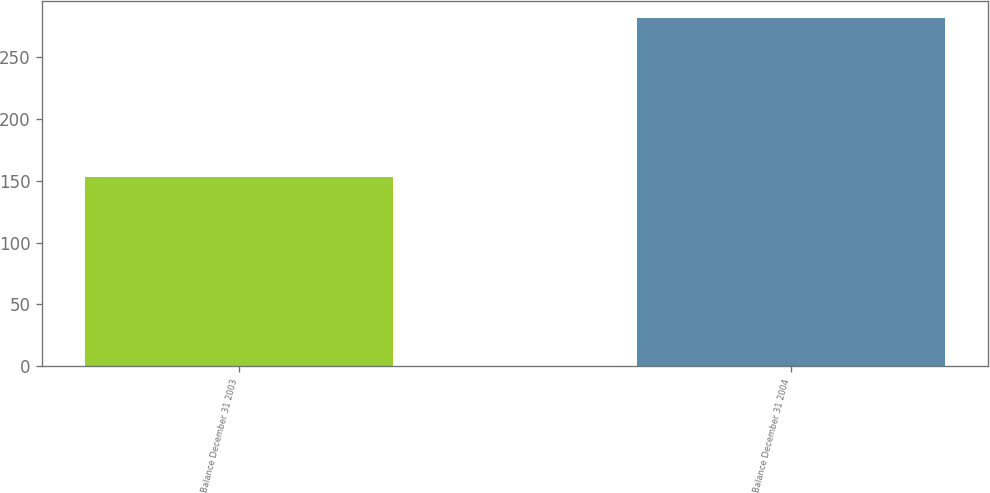<chart> <loc_0><loc_0><loc_500><loc_500><bar_chart><fcel>Balance December 31 2003<fcel>Balance December 31 2004<nl><fcel>153<fcel>281<nl></chart> 